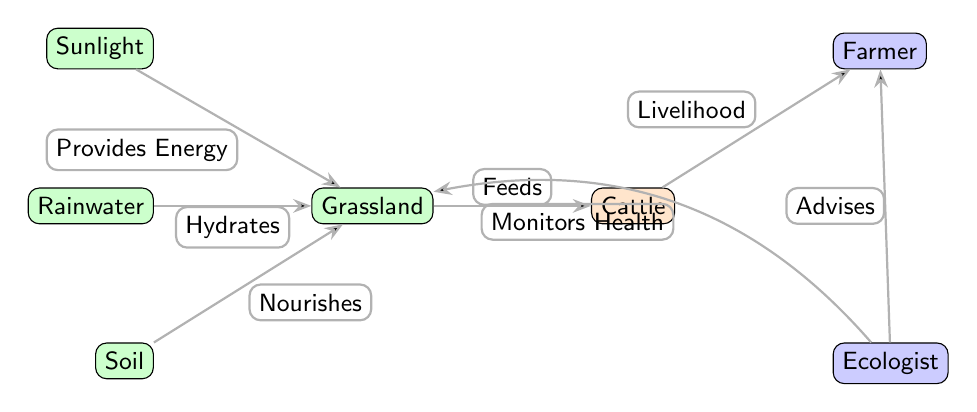What do cattle feed on? The diagram shows a direct flow from the grassland to cattle, indicating that cattle feed on grassland.
Answer: Grassland How many resources are present in the diagram? The diagram includes four resource nodes: sunlight, rainwater, soil, and grassland. Thus, there are four resources.
Answer: 4 Who advises the farmer? The diagram indicates a direct edge from the ecologist to the farmer, signifying that the ecologist advises the farmer.
Answer: Ecologist What does sunlight provide to grassland? The edge from sunlight to grassland is labeled "Provides Energy," which indicates that sunlight provides energy to grassland.
Answer: Energy What relationship exists between the farmer and cattle? The edge from cattle to farmer is labeled "Livelihood," indicating that the relationship is one in which cattle provide a livelihood for the farmer.
Answer: Livelihood What flows from soil to grassland? The diagram shows an edge from soil to grassland labeled "Nourishes," which captures the flow of nourishment from soil to grassland.
Answer: Nourishment How does the ecologist contribute to grassland? The ecologist monitors the health of grassland, as indicated by the labeled edge connecting the ecologist to the grassland in the diagram.
Answer: Monitors Health What is the purpose of rainwater in the diagram? The edge from rainwater to grassland is labeled "Hydrates," which indicates that rainwater provides hydration to grassland.
Answer: Hydrates Which two human roles are depicted in the diagram? The diagram identifies two human roles, the farmer and the ecologist, each tied to their respective functions in relation to cattle and grassland.
Answer: Farmer, Ecologist 